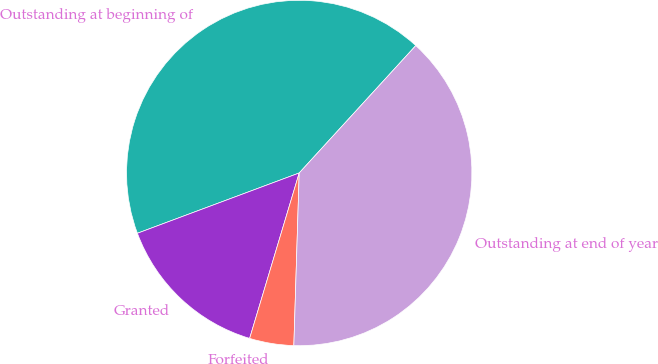Convert chart to OTSL. <chart><loc_0><loc_0><loc_500><loc_500><pie_chart><fcel>Outstanding at beginning of<fcel>Granted<fcel>Forfeited<fcel>Outstanding at end of year<nl><fcel>42.47%<fcel>14.69%<fcel>4.14%<fcel>38.7%<nl></chart> 